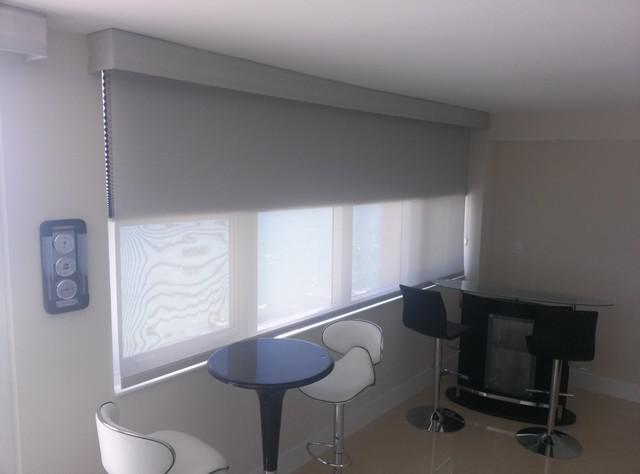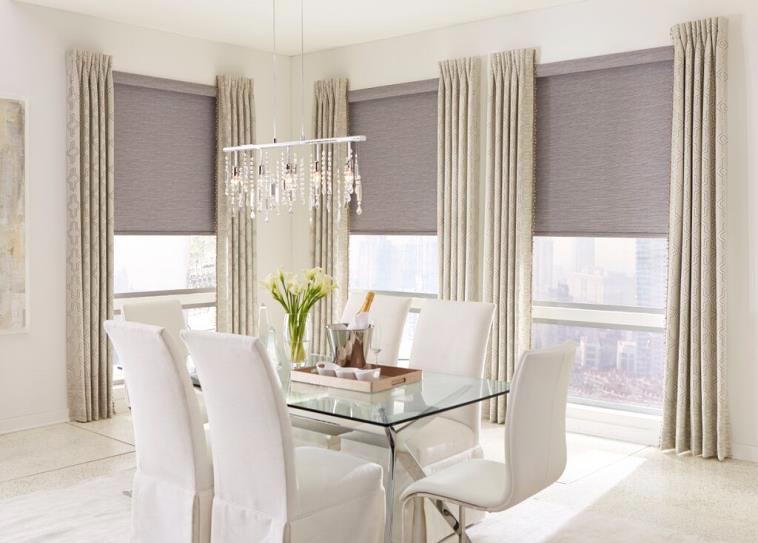The first image is the image on the left, the second image is the image on the right. For the images shown, is this caption "There are exactly three window shades." true? Answer yes or no. No. The first image is the image on the left, the second image is the image on the right. Assess this claim about the two images: "The left and right image contains a total of three blinds.". Correct or not? Answer yes or no. No. 